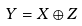Convert formula to latex. <formula><loc_0><loc_0><loc_500><loc_500>Y = X \oplus Z</formula> 